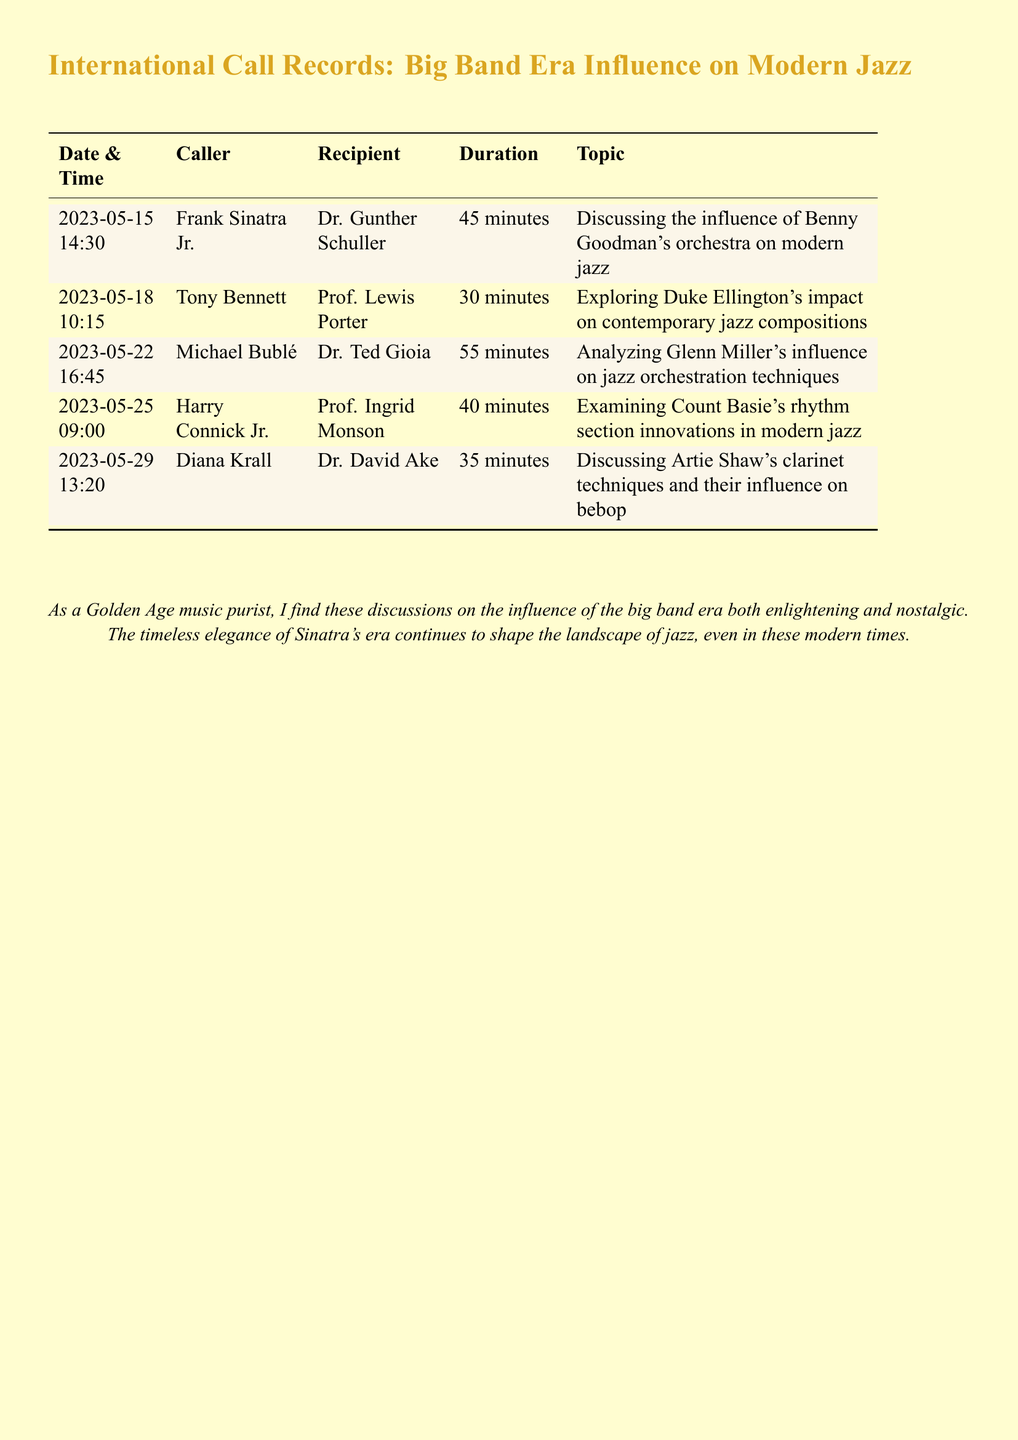what is the date of the first call? The first call is on May 15, 2023.
Answer: May 15, 2023 who called Dr. Gunther Schuller? The caller of Dr. Gunther Schuller is Frank Sinatra Jr.
Answer: Frank Sinatra Jr how long was the call between Tony Bennett and Prof. Lewis Porter? The duration of the call between Tony Bennett and Prof. Lewis Porter is 30 minutes.
Answer: 30 minutes what was the topic of the call on May 22, 2023? The topic of the call on May 22, 2023, was analyzing Glenn Miller's influence on jazz orchestration techniques.
Answer: Analyzing Glenn Miller's influence on jazz orchestration techniques which two musicians discussed Count Basie's rhythm section innovations? The musicians who discussed Count Basie's innovations are Harry Connick Jr. and Prof. Ingrid Monson.
Answer: Harry Connick Jr. and Prof. Ingrid Monson how many calls were made in total? The document lists a total of five calls.
Answer: Five what influence did Artie Shaw have on modern jazz according to the last call? The influence discussed was on clarinet techniques.
Answer: Clarinet techniques who was the recipient of the call on May 25, 2023? The recipient of the call on May 25, 2023, is Prof. Ingrid Monson.
Answer: Prof. Ingrid Monson in what year was the last call made? The last call was made in the year 2023.
Answer: 2023 